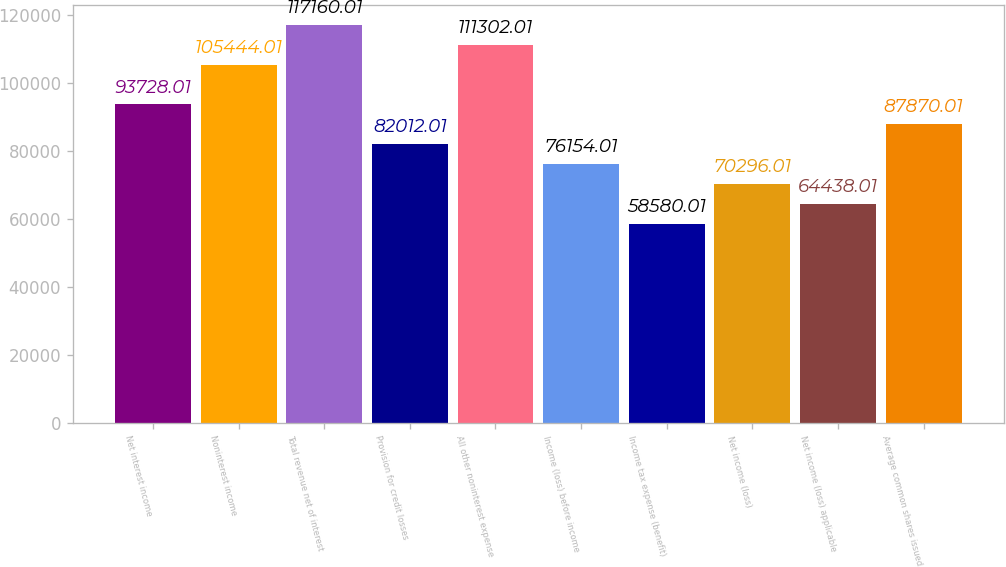Convert chart to OTSL. <chart><loc_0><loc_0><loc_500><loc_500><bar_chart><fcel>Net interest income<fcel>Noninterest income<fcel>Total revenue net of interest<fcel>Provision for credit losses<fcel>All other noninterest expense<fcel>Income (loss) before income<fcel>Income tax expense (benefit)<fcel>Net income (loss)<fcel>Net income (loss) applicable<fcel>Average common shares issued<nl><fcel>93728<fcel>105444<fcel>117160<fcel>82012<fcel>111302<fcel>76154<fcel>58580<fcel>70296<fcel>64438<fcel>87870<nl></chart> 